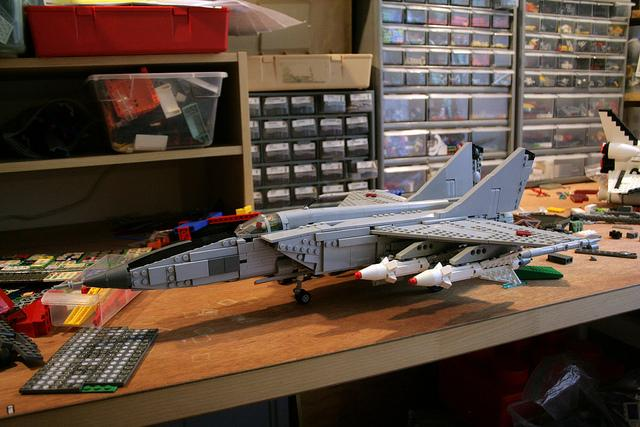What was used to build this plane? Please explain your reasoning. legos. The materials used for the construction of the plane contain little indentations which can be snapped into place and are consistent with this type of toy. 